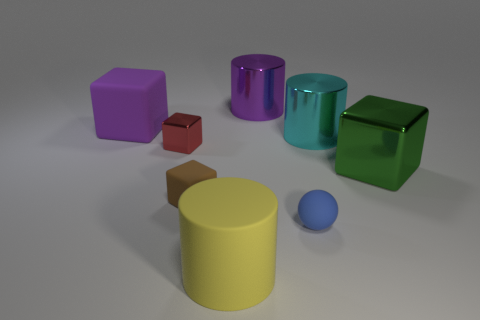Can you describe the size and color of the objects at the center? At the center of the image, we see a prominent yellow cylindrical object with a relatively large size compared to the others. In front of it, there's a small blue rubber ball. The yellow cylinder's vibrant color and substantive shape draw the eye. 